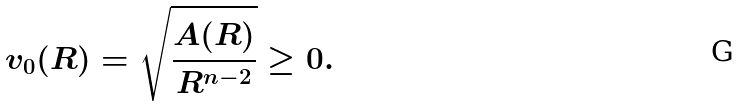Convert formula to latex. <formula><loc_0><loc_0><loc_500><loc_500>v _ { 0 } ( R ) = \sqrt { \frac { A ( R ) } { R ^ { n - 2 } } } \geq 0 .</formula> 